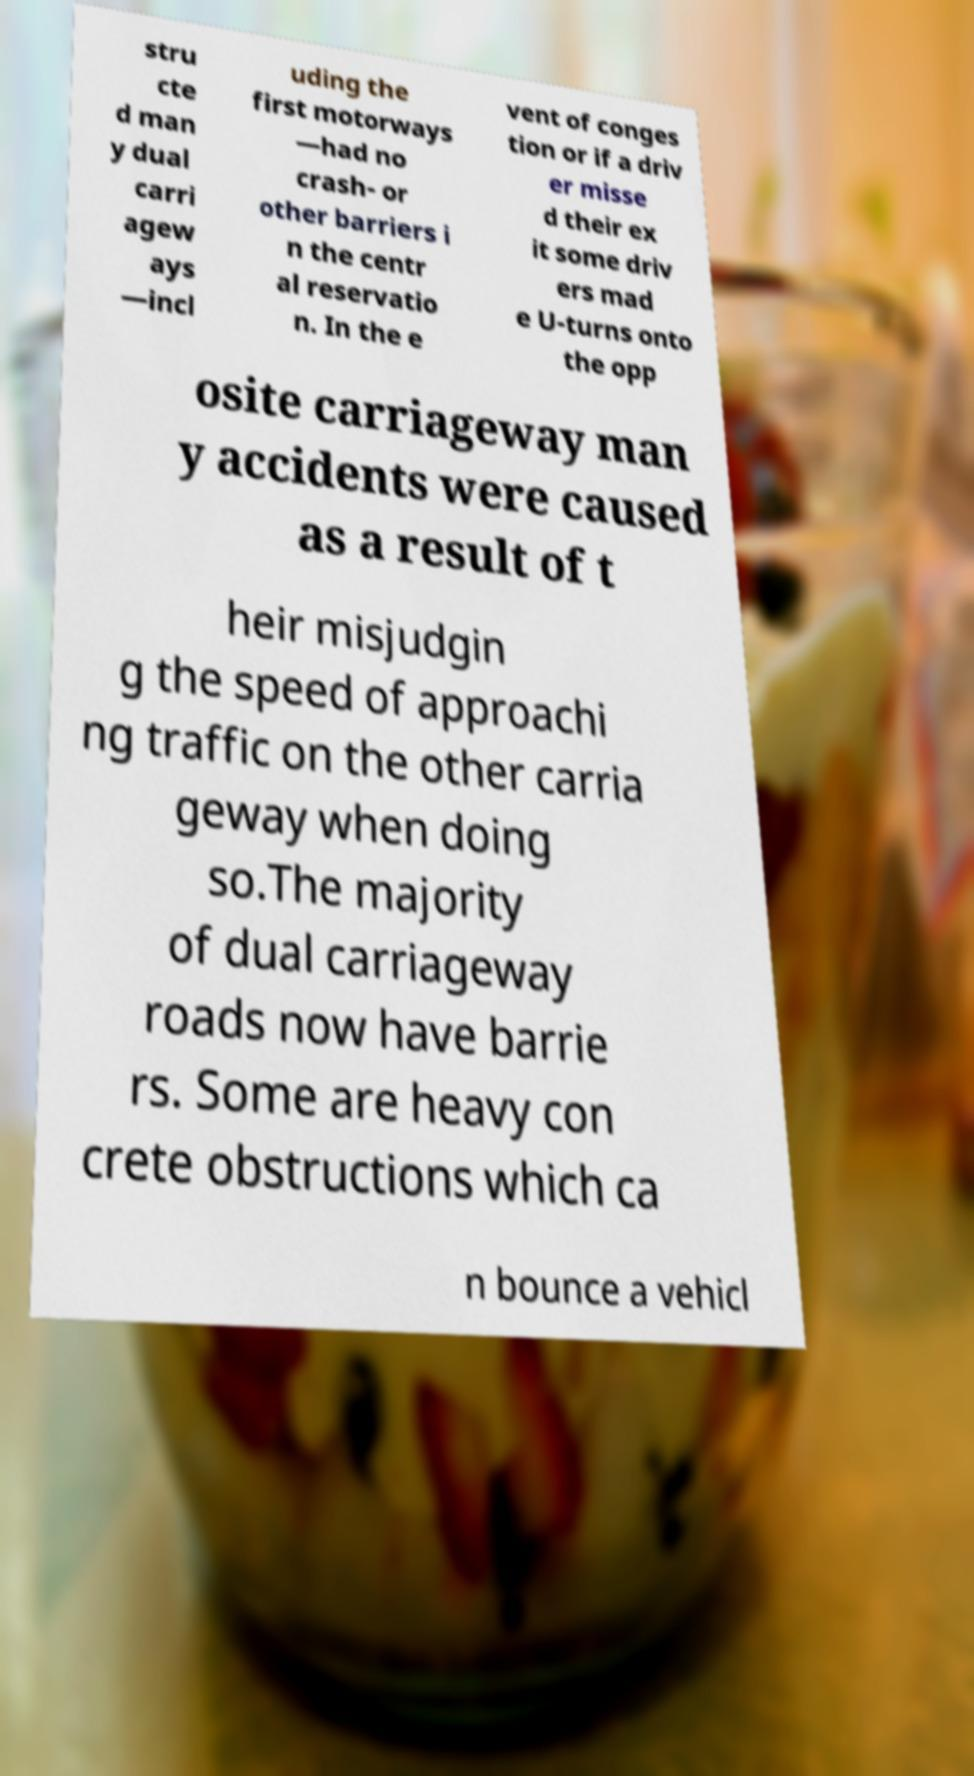I need the written content from this picture converted into text. Can you do that? stru cte d man y dual carri agew ays —incl uding the first motorways —had no crash- or other barriers i n the centr al reservatio n. In the e vent of conges tion or if a driv er misse d their ex it some driv ers mad e U-turns onto the opp osite carriageway man y accidents were caused as a result of t heir misjudgin g the speed of approachi ng traffic on the other carria geway when doing so.The majority of dual carriageway roads now have barrie rs. Some are heavy con crete obstructions which ca n bounce a vehicl 